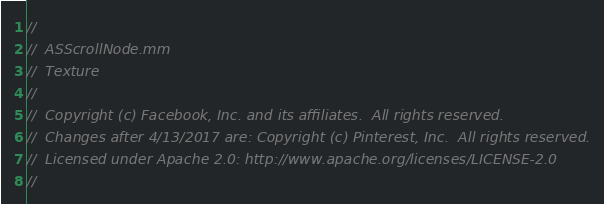Convert code to text. <code><loc_0><loc_0><loc_500><loc_500><_ObjectiveC_>//
//  ASScrollNode.mm
//  Texture
//
//  Copyright (c) Facebook, Inc. and its affiliates.  All rights reserved.
//  Changes after 4/13/2017 are: Copyright (c) Pinterest, Inc.  All rights reserved.
//  Licensed under Apache 2.0: http://www.apache.org/licenses/LICENSE-2.0
//
</code> 